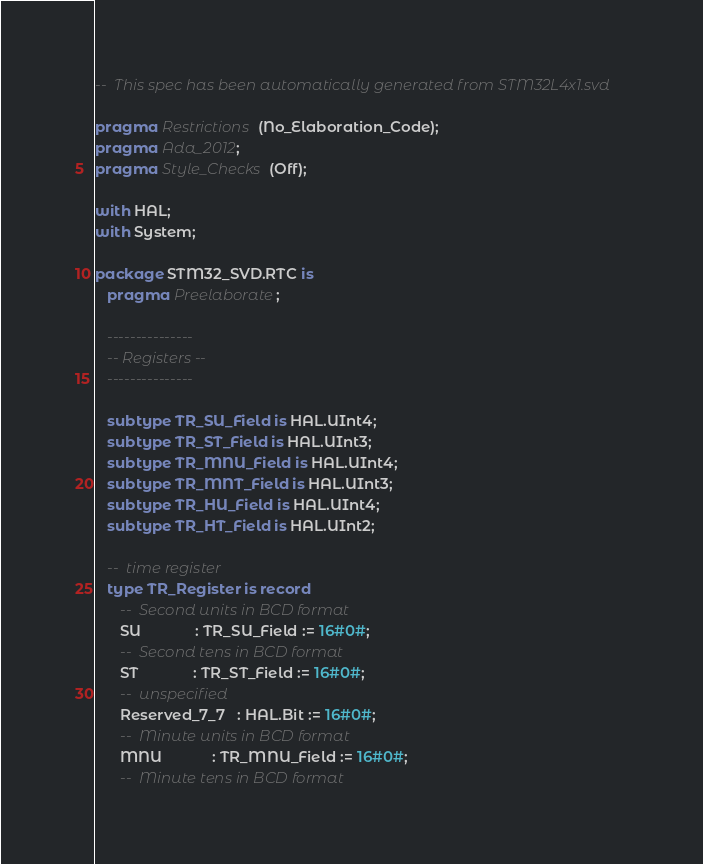Convert code to text. <code><loc_0><loc_0><loc_500><loc_500><_Ada_>--  This spec has been automatically generated from STM32L4x1.svd

pragma Restrictions (No_Elaboration_Code);
pragma Ada_2012;
pragma Style_Checks (Off);

with HAL;
with System;

package STM32_SVD.RTC is
   pragma Preelaborate;

   ---------------
   -- Registers --
   ---------------

   subtype TR_SU_Field is HAL.UInt4;
   subtype TR_ST_Field is HAL.UInt3;
   subtype TR_MNU_Field is HAL.UInt4;
   subtype TR_MNT_Field is HAL.UInt3;
   subtype TR_HU_Field is HAL.UInt4;
   subtype TR_HT_Field is HAL.UInt2;

   --  time register
   type TR_Register is record
      --  Second units in BCD format
      SU             : TR_SU_Field := 16#0#;
      --  Second tens in BCD format
      ST             : TR_ST_Field := 16#0#;
      --  unspecified
      Reserved_7_7   : HAL.Bit := 16#0#;
      --  Minute units in BCD format
      MNU            : TR_MNU_Field := 16#0#;
      --  Minute tens in BCD format</code> 